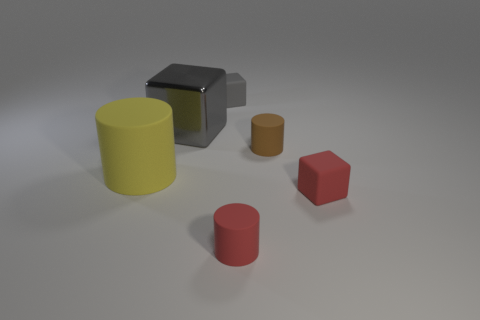Are any of the objects casting shadows? Yes, each object casts a subtle shadow due to the lighting setup, which suggests a single light source coming from the top right direction, given the orientation and position of the shadows. How can the direction of the lighting be determined from the shadows? The direction and length of shadows in the image help reveal the light's direction. Shadows extend opposite to the light source, so when we observe the shadows falling toward the bottom left, we can infer that the light originates from top right. 